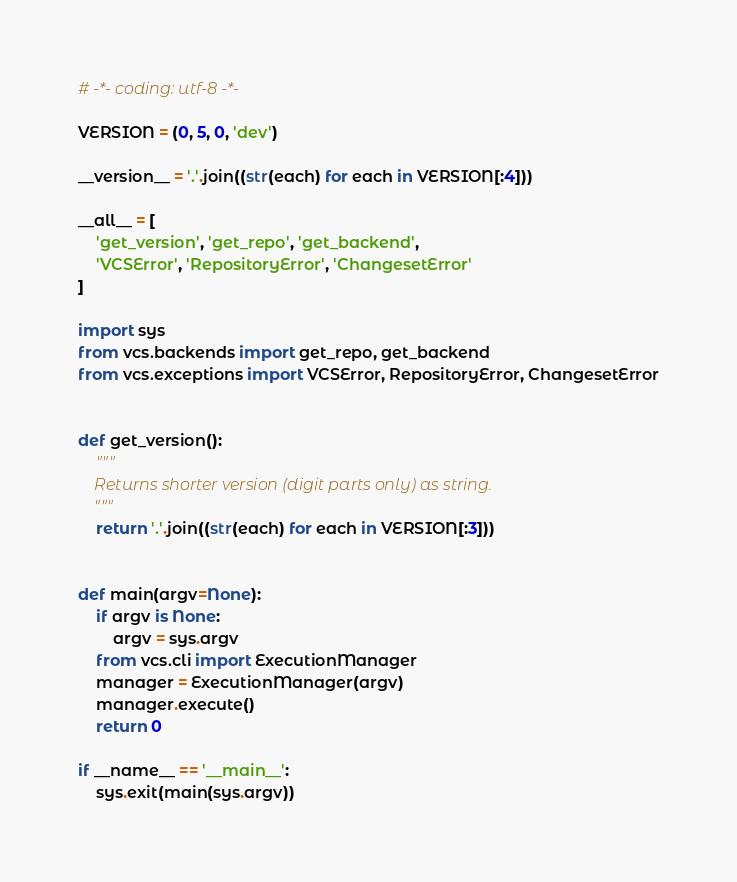<code> <loc_0><loc_0><loc_500><loc_500><_Python_># -*- coding: utf-8 -*-

VERSION = (0, 5, 0, 'dev')

__version__ = '.'.join((str(each) for each in VERSION[:4]))

__all__ = [
    'get_version', 'get_repo', 'get_backend',
    'VCSError', 'RepositoryError', 'ChangesetError'
]

import sys
from vcs.backends import get_repo, get_backend
from vcs.exceptions import VCSError, RepositoryError, ChangesetError


def get_version():
    """
    Returns shorter version (digit parts only) as string.
    """
    return '.'.join((str(each) for each in VERSION[:3]))


def main(argv=None):
    if argv is None:
        argv = sys.argv
    from vcs.cli import ExecutionManager
    manager = ExecutionManager(argv)
    manager.execute()
    return 0

if __name__ == '__main__':
    sys.exit(main(sys.argv))
</code> 